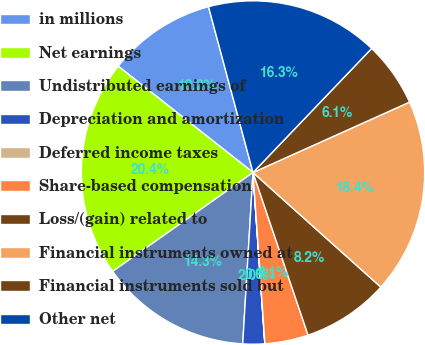Convert chart to OTSL. <chart><loc_0><loc_0><loc_500><loc_500><pie_chart><fcel>in millions<fcel>Net earnings<fcel>Undistributed earnings of<fcel>Depreciation and amortization<fcel>Deferred income taxes<fcel>Share-based compensation<fcel>Loss/(gain) related to<fcel>Financial instruments owned at<fcel>Financial instruments sold but<fcel>Other net<nl><fcel>10.2%<fcel>20.4%<fcel>14.28%<fcel>2.05%<fcel>0.01%<fcel>4.09%<fcel>8.17%<fcel>18.36%<fcel>6.13%<fcel>16.32%<nl></chart> 